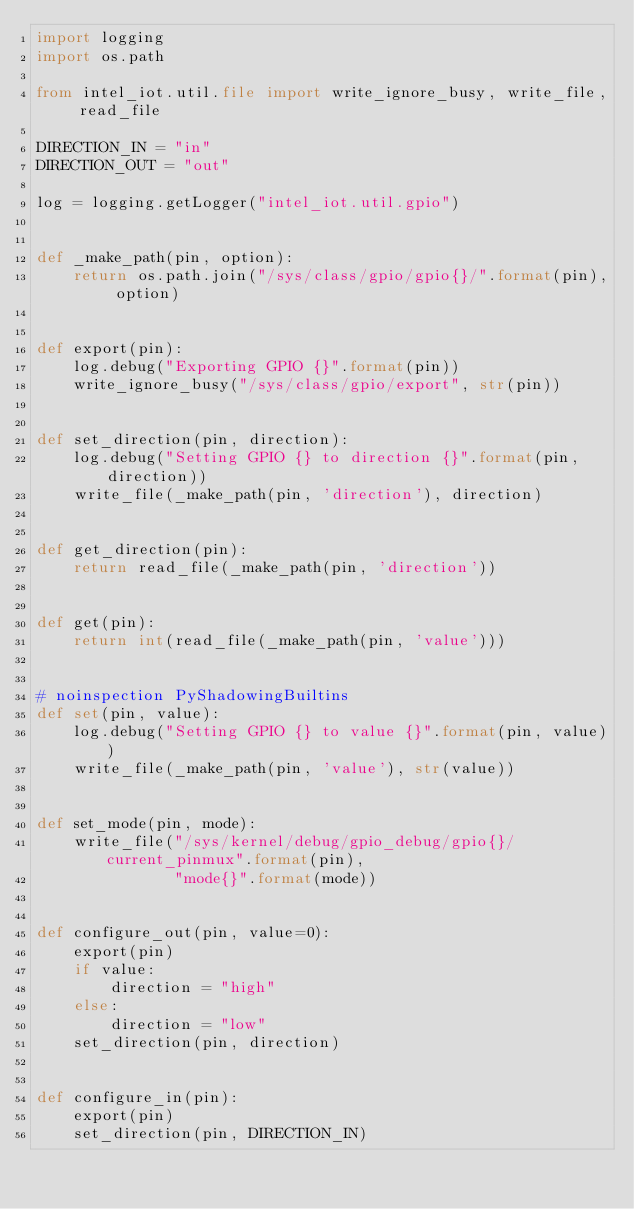Convert code to text. <code><loc_0><loc_0><loc_500><loc_500><_Python_>import logging
import os.path

from intel_iot.util.file import write_ignore_busy, write_file, read_file

DIRECTION_IN = "in"
DIRECTION_OUT = "out"

log = logging.getLogger("intel_iot.util.gpio")


def _make_path(pin, option):
    return os.path.join("/sys/class/gpio/gpio{}/".format(pin), option)


def export(pin):
    log.debug("Exporting GPIO {}".format(pin))
    write_ignore_busy("/sys/class/gpio/export", str(pin))


def set_direction(pin, direction):
    log.debug("Setting GPIO {} to direction {}".format(pin, direction))
    write_file(_make_path(pin, 'direction'), direction)


def get_direction(pin):
    return read_file(_make_path(pin, 'direction'))


def get(pin):
    return int(read_file(_make_path(pin, 'value')))


# noinspection PyShadowingBuiltins
def set(pin, value):
    log.debug("Setting GPIO {} to value {}".format(pin, value))
    write_file(_make_path(pin, 'value'), str(value))


def set_mode(pin, mode):
    write_file("/sys/kernel/debug/gpio_debug/gpio{}/current_pinmux".format(pin),
               "mode{}".format(mode))


def configure_out(pin, value=0):
    export(pin)
    if value:
        direction = "high"
    else:
        direction = "low"
    set_direction(pin, direction)


def configure_in(pin):
    export(pin)
    set_direction(pin, DIRECTION_IN)
</code> 